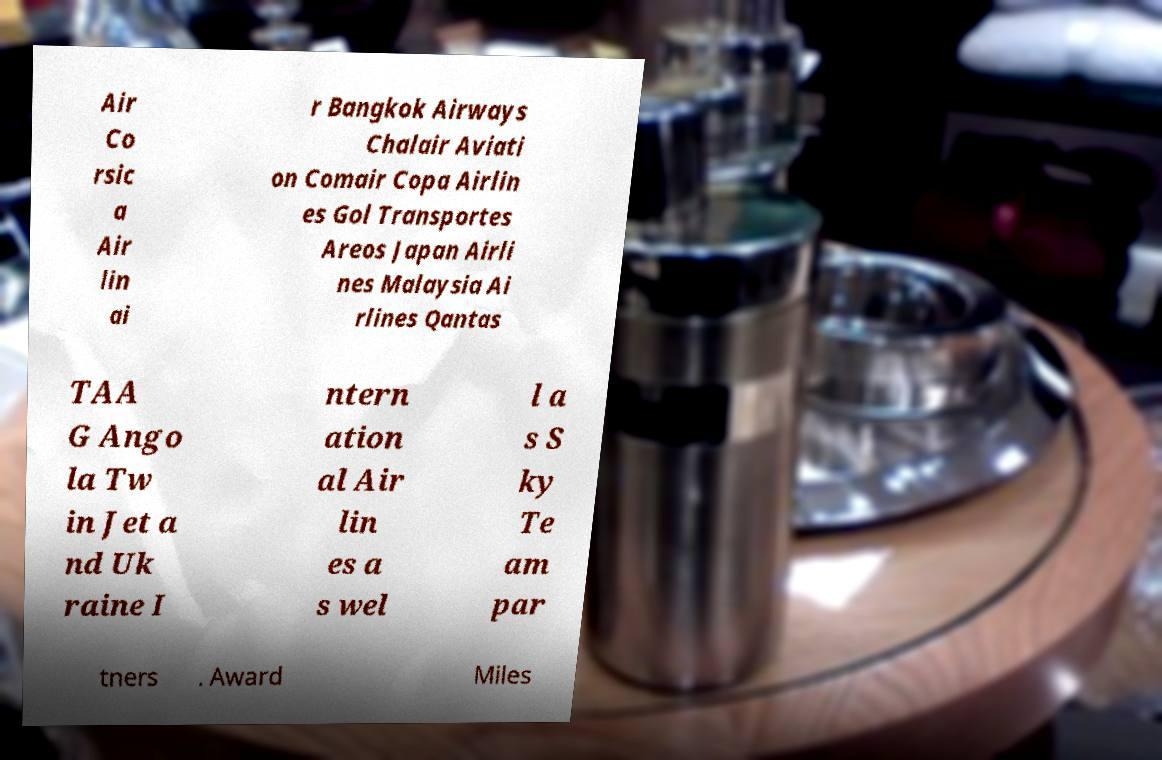There's text embedded in this image that I need extracted. Can you transcribe it verbatim? Air Co rsic a Air lin ai r Bangkok Airways Chalair Aviati on Comair Copa Airlin es Gol Transportes Areos Japan Airli nes Malaysia Ai rlines Qantas TAA G Ango la Tw in Jet a nd Uk raine I ntern ation al Air lin es a s wel l a s S ky Te am par tners . Award Miles 